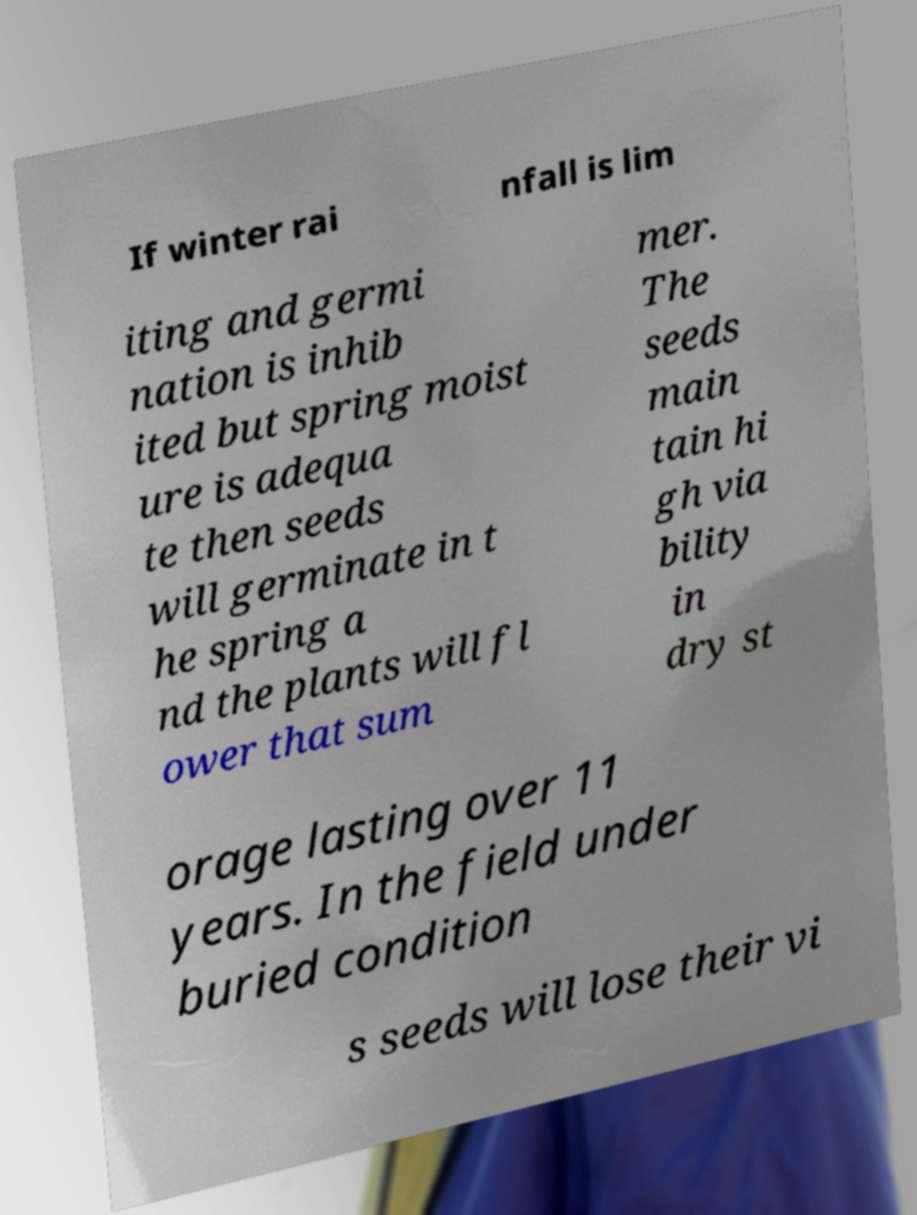Can you read and provide the text displayed in the image?This photo seems to have some interesting text. Can you extract and type it out for me? If winter rai nfall is lim iting and germi nation is inhib ited but spring moist ure is adequa te then seeds will germinate in t he spring a nd the plants will fl ower that sum mer. The seeds main tain hi gh via bility in dry st orage lasting over 11 years. In the field under buried condition s seeds will lose their vi 